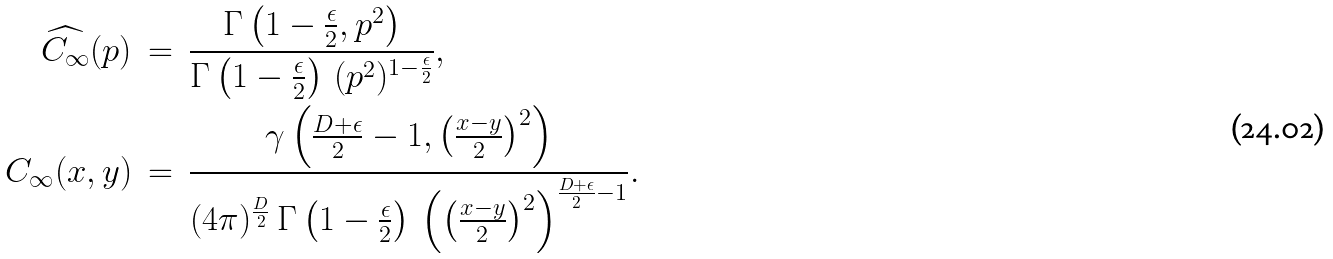<formula> <loc_0><loc_0><loc_500><loc_500>\widehat { C _ { \infty } } ( p ) & \, = \, \frac { \Gamma \left ( 1 - \frac { \epsilon } { 2 } , p ^ { 2 } \right ) } { \Gamma \left ( 1 - \frac { \epsilon } { 2 } \right ) \, ( p ^ { 2 } ) ^ { 1 - \frac { \epsilon } { 2 } } } , \\ C _ { \infty } ( x , y ) & \, = \, \frac { \gamma \left ( \frac { D + \epsilon } { 2 } - 1 , \left ( \frac { x - y } { 2 } \right ) ^ { 2 } \right ) } { ( 4 \pi ) ^ { \frac { D } { 2 } } \, \Gamma \left ( 1 - \frac { \epsilon } { 2 } \right ) \, \left ( \left ( \frac { x - y } { 2 } \right ) ^ { 2 } \right ) ^ { \frac { D + \epsilon } { 2 } - 1 } } .</formula> 